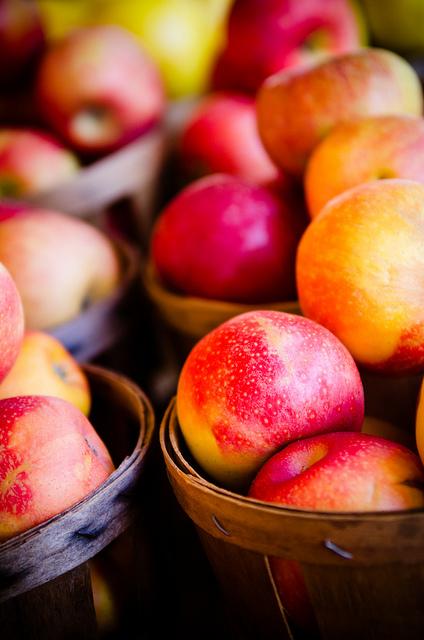How many fruits are seen?
Write a very short answer. 1. What holds the fruit?
Concise answer only. Basket. What kind of fruit are these?
Write a very short answer. Apples. 